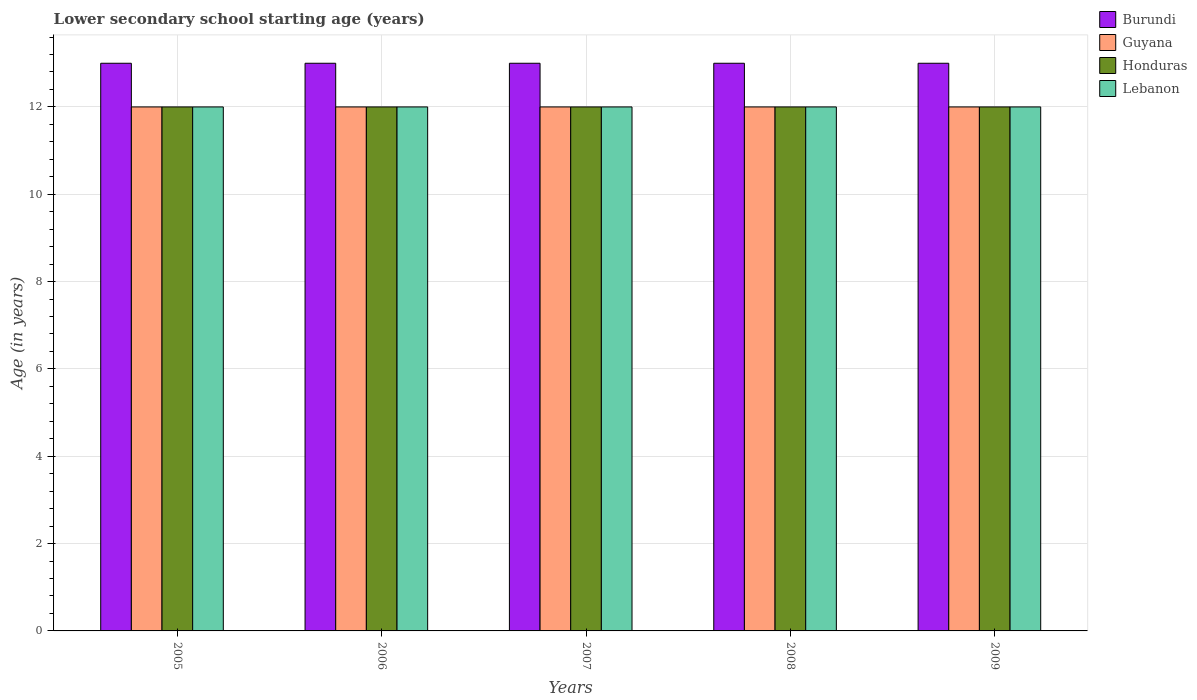Are the number of bars on each tick of the X-axis equal?
Your response must be concise. Yes. How many bars are there on the 1st tick from the left?
Offer a very short reply. 4. In how many cases, is the number of bars for a given year not equal to the number of legend labels?
Provide a succinct answer. 0. What is the lower secondary school starting age of children in Guyana in 2006?
Provide a short and direct response. 12. Across all years, what is the maximum lower secondary school starting age of children in Honduras?
Make the answer very short. 12. Across all years, what is the minimum lower secondary school starting age of children in Honduras?
Offer a very short reply. 12. In which year was the lower secondary school starting age of children in Guyana maximum?
Give a very brief answer. 2005. What is the total lower secondary school starting age of children in Lebanon in the graph?
Your response must be concise. 60. In the year 2005, what is the difference between the lower secondary school starting age of children in Lebanon and lower secondary school starting age of children in Burundi?
Ensure brevity in your answer.  -1. In how many years, is the lower secondary school starting age of children in Burundi greater than 11.6 years?
Give a very brief answer. 5. What is the ratio of the lower secondary school starting age of children in Burundi in 2005 to that in 2007?
Your response must be concise. 1. Is the lower secondary school starting age of children in Honduras in 2006 less than that in 2009?
Provide a succinct answer. No. Is the difference between the lower secondary school starting age of children in Lebanon in 2007 and 2009 greater than the difference between the lower secondary school starting age of children in Burundi in 2007 and 2009?
Offer a very short reply. No. What is the difference between the highest and the second highest lower secondary school starting age of children in Guyana?
Make the answer very short. 0. What is the difference between the highest and the lowest lower secondary school starting age of children in Guyana?
Offer a very short reply. 0. In how many years, is the lower secondary school starting age of children in Guyana greater than the average lower secondary school starting age of children in Guyana taken over all years?
Your answer should be compact. 0. Is the sum of the lower secondary school starting age of children in Burundi in 2008 and 2009 greater than the maximum lower secondary school starting age of children in Honduras across all years?
Give a very brief answer. Yes. What does the 3rd bar from the left in 2006 represents?
Keep it short and to the point. Honduras. What does the 3rd bar from the right in 2009 represents?
Ensure brevity in your answer.  Guyana. Is it the case that in every year, the sum of the lower secondary school starting age of children in Honduras and lower secondary school starting age of children in Guyana is greater than the lower secondary school starting age of children in Burundi?
Your answer should be very brief. Yes. What is the difference between two consecutive major ticks on the Y-axis?
Provide a succinct answer. 2. What is the title of the graph?
Make the answer very short. Lower secondary school starting age (years). Does "Italy" appear as one of the legend labels in the graph?
Your answer should be compact. No. What is the label or title of the X-axis?
Give a very brief answer. Years. What is the label or title of the Y-axis?
Make the answer very short. Age (in years). What is the Age (in years) of Lebanon in 2005?
Offer a terse response. 12. What is the Age (in years) of Guyana in 2006?
Offer a very short reply. 12. What is the Age (in years) in Honduras in 2006?
Keep it short and to the point. 12. What is the Age (in years) of Guyana in 2007?
Provide a succinct answer. 12. What is the Age (in years) in Honduras in 2007?
Offer a very short reply. 12. What is the Age (in years) in Burundi in 2008?
Provide a succinct answer. 13. What is the Age (in years) of Lebanon in 2008?
Your answer should be compact. 12. What is the Age (in years) in Burundi in 2009?
Make the answer very short. 13. What is the Age (in years) of Guyana in 2009?
Your answer should be compact. 12. What is the Age (in years) in Honduras in 2009?
Your response must be concise. 12. Across all years, what is the maximum Age (in years) of Burundi?
Offer a very short reply. 13. Across all years, what is the maximum Age (in years) in Honduras?
Your response must be concise. 12. Across all years, what is the minimum Age (in years) of Honduras?
Ensure brevity in your answer.  12. What is the total Age (in years) of Honduras in the graph?
Offer a very short reply. 60. What is the difference between the Age (in years) of Guyana in 2005 and that in 2006?
Ensure brevity in your answer.  0. What is the difference between the Age (in years) of Guyana in 2005 and that in 2007?
Provide a short and direct response. 0. What is the difference between the Age (in years) of Honduras in 2005 and that in 2007?
Ensure brevity in your answer.  0. What is the difference between the Age (in years) in Lebanon in 2005 and that in 2007?
Your response must be concise. 0. What is the difference between the Age (in years) of Burundi in 2005 and that in 2008?
Offer a terse response. 0. What is the difference between the Age (in years) in Guyana in 2005 and that in 2008?
Make the answer very short. 0. What is the difference between the Age (in years) of Guyana in 2005 and that in 2009?
Your response must be concise. 0. What is the difference between the Age (in years) in Honduras in 2005 and that in 2009?
Your answer should be very brief. 0. What is the difference between the Age (in years) in Lebanon in 2005 and that in 2009?
Give a very brief answer. 0. What is the difference between the Age (in years) of Guyana in 2006 and that in 2007?
Make the answer very short. 0. What is the difference between the Age (in years) in Honduras in 2006 and that in 2007?
Your answer should be very brief. 0. What is the difference between the Age (in years) of Lebanon in 2006 and that in 2007?
Ensure brevity in your answer.  0. What is the difference between the Age (in years) of Guyana in 2006 and that in 2008?
Your answer should be compact. 0. What is the difference between the Age (in years) in Honduras in 2006 and that in 2008?
Your answer should be very brief. 0. What is the difference between the Age (in years) of Lebanon in 2006 and that in 2008?
Keep it short and to the point. 0. What is the difference between the Age (in years) in Burundi in 2006 and that in 2009?
Provide a short and direct response. 0. What is the difference between the Age (in years) in Honduras in 2006 and that in 2009?
Offer a terse response. 0. What is the difference between the Age (in years) in Lebanon in 2006 and that in 2009?
Your answer should be compact. 0. What is the difference between the Age (in years) of Guyana in 2007 and that in 2008?
Your response must be concise. 0. What is the difference between the Age (in years) in Lebanon in 2007 and that in 2009?
Offer a very short reply. 0. What is the difference between the Age (in years) of Burundi in 2008 and that in 2009?
Your response must be concise. 0. What is the difference between the Age (in years) of Burundi in 2005 and the Age (in years) of Guyana in 2006?
Your response must be concise. 1. What is the difference between the Age (in years) in Guyana in 2005 and the Age (in years) in Honduras in 2006?
Your answer should be very brief. 0. What is the difference between the Age (in years) in Guyana in 2005 and the Age (in years) in Lebanon in 2006?
Offer a terse response. 0. What is the difference between the Age (in years) of Honduras in 2005 and the Age (in years) of Lebanon in 2006?
Offer a terse response. 0. What is the difference between the Age (in years) of Guyana in 2005 and the Age (in years) of Honduras in 2007?
Make the answer very short. 0. What is the difference between the Age (in years) of Honduras in 2005 and the Age (in years) of Lebanon in 2007?
Offer a terse response. 0. What is the difference between the Age (in years) of Burundi in 2005 and the Age (in years) of Guyana in 2008?
Offer a terse response. 1. What is the difference between the Age (in years) in Honduras in 2005 and the Age (in years) in Lebanon in 2008?
Make the answer very short. 0. What is the difference between the Age (in years) in Burundi in 2005 and the Age (in years) in Honduras in 2009?
Make the answer very short. 1. What is the difference between the Age (in years) of Guyana in 2005 and the Age (in years) of Honduras in 2009?
Make the answer very short. 0. What is the difference between the Age (in years) in Honduras in 2005 and the Age (in years) in Lebanon in 2009?
Your answer should be very brief. 0. What is the difference between the Age (in years) of Burundi in 2006 and the Age (in years) of Guyana in 2007?
Keep it short and to the point. 1. What is the difference between the Age (in years) in Burundi in 2006 and the Age (in years) in Honduras in 2007?
Ensure brevity in your answer.  1. What is the difference between the Age (in years) of Burundi in 2006 and the Age (in years) of Lebanon in 2007?
Provide a short and direct response. 1. What is the difference between the Age (in years) of Guyana in 2006 and the Age (in years) of Lebanon in 2007?
Provide a short and direct response. 0. What is the difference between the Age (in years) of Burundi in 2006 and the Age (in years) of Lebanon in 2008?
Keep it short and to the point. 1. What is the difference between the Age (in years) in Honduras in 2006 and the Age (in years) in Lebanon in 2008?
Keep it short and to the point. 0. What is the difference between the Age (in years) of Burundi in 2006 and the Age (in years) of Guyana in 2009?
Your response must be concise. 1. What is the difference between the Age (in years) of Burundi in 2006 and the Age (in years) of Honduras in 2009?
Offer a terse response. 1. What is the difference between the Age (in years) in Guyana in 2006 and the Age (in years) in Honduras in 2009?
Give a very brief answer. 0. What is the difference between the Age (in years) of Guyana in 2006 and the Age (in years) of Lebanon in 2009?
Offer a terse response. 0. What is the difference between the Age (in years) of Burundi in 2007 and the Age (in years) of Guyana in 2008?
Offer a very short reply. 1. What is the difference between the Age (in years) in Burundi in 2007 and the Age (in years) in Lebanon in 2008?
Provide a succinct answer. 1. What is the difference between the Age (in years) in Honduras in 2007 and the Age (in years) in Lebanon in 2008?
Your answer should be very brief. 0. What is the difference between the Age (in years) of Burundi in 2007 and the Age (in years) of Guyana in 2009?
Provide a short and direct response. 1. What is the difference between the Age (in years) in Burundi in 2007 and the Age (in years) in Honduras in 2009?
Your answer should be very brief. 1. What is the difference between the Age (in years) in Guyana in 2007 and the Age (in years) in Honduras in 2009?
Give a very brief answer. 0. What is the difference between the Age (in years) of Burundi in 2008 and the Age (in years) of Guyana in 2009?
Offer a very short reply. 1. What is the difference between the Age (in years) of Burundi in 2008 and the Age (in years) of Lebanon in 2009?
Ensure brevity in your answer.  1. What is the difference between the Age (in years) in Guyana in 2008 and the Age (in years) in Honduras in 2009?
Ensure brevity in your answer.  0. What is the difference between the Age (in years) of Guyana in 2008 and the Age (in years) of Lebanon in 2009?
Provide a succinct answer. 0. In the year 2005, what is the difference between the Age (in years) in Burundi and Age (in years) in Guyana?
Give a very brief answer. 1. In the year 2005, what is the difference between the Age (in years) in Burundi and Age (in years) in Honduras?
Keep it short and to the point. 1. In the year 2005, what is the difference between the Age (in years) in Burundi and Age (in years) in Lebanon?
Your answer should be compact. 1. In the year 2005, what is the difference between the Age (in years) in Guyana and Age (in years) in Honduras?
Your answer should be very brief. 0. In the year 2005, what is the difference between the Age (in years) in Guyana and Age (in years) in Lebanon?
Keep it short and to the point. 0. In the year 2005, what is the difference between the Age (in years) in Honduras and Age (in years) in Lebanon?
Give a very brief answer. 0. In the year 2006, what is the difference between the Age (in years) of Burundi and Age (in years) of Guyana?
Make the answer very short. 1. In the year 2006, what is the difference between the Age (in years) in Burundi and Age (in years) in Honduras?
Provide a succinct answer. 1. In the year 2006, what is the difference between the Age (in years) of Burundi and Age (in years) of Lebanon?
Make the answer very short. 1. In the year 2006, what is the difference between the Age (in years) of Guyana and Age (in years) of Honduras?
Give a very brief answer. 0. In the year 2006, what is the difference between the Age (in years) of Honduras and Age (in years) of Lebanon?
Offer a very short reply. 0. In the year 2007, what is the difference between the Age (in years) in Burundi and Age (in years) in Lebanon?
Your answer should be compact. 1. In the year 2007, what is the difference between the Age (in years) in Guyana and Age (in years) in Honduras?
Your answer should be compact. 0. In the year 2007, what is the difference between the Age (in years) of Guyana and Age (in years) of Lebanon?
Make the answer very short. 0. In the year 2007, what is the difference between the Age (in years) of Honduras and Age (in years) of Lebanon?
Provide a succinct answer. 0. In the year 2008, what is the difference between the Age (in years) of Burundi and Age (in years) of Guyana?
Your answer should be very brief. 1. In the year 2008, what is the difference between the Age (in years) in Burundi and Age (in years) in Honduras?
Keep it short and to the point. 1. In the year 2008, what is the difference between the Age (in years) in Burundi and Age (in years) in Lebanon?
Offer a very short reply. 1. In the year 2008, what is the difference between the Age (in years) in Guyana and Age (in years) in Honduras?
Provide a succinct answer. 0. In the year 2008, what is the difference between the Age (in years) of Honduras and Age (in years) of Lebanon?
Your response must be concise. 0. In the year 2009, what is the difference between the Age (in years) in Burundi and Age (in years) in Guyana?
Keep it short and to the point. 1. In the year 2009, what is the difference between the Age (in years) in Guyana and Age (in years) in Lebanon?
Offer a very short reply. 0. In the year 2009, what is the difference between the Age (in years) in Honduras and Age (in years) in Lebanon?
Give a very brief answer. 0. What is the ratio of the Age (in years) of Guyana in 2005 to that in 2006?
Your answer should be very brief. 1. What is the ratio of the Age (in years) of Honduras in 2005 to that in 2006?
Give a very brief answer. 1. What is the ratio of the Age (in years) of Lebanon in 2005 to that in 2006?
Offer a terse response. 1. What is the ratio of the Age (in years) of Guyana in 2005 to that in 2007?
Offer a terse response. 1. What is the ratio of the Age (in years) in Honduras in 2005 to that in 2007?
Offer a very short reply. 1. What is the ratio of the Age (in years) in Lebanon in 2005 to that in 2007?
Ensure brevity in your answer.  1. What is the ratio of the Age (in years) of Guyana in 2005 to that in 2008?
Provide a succinct answer. 1. What is the ratio of the Age (in years) in Guyana in 2005 to that in 2009?
Make the answer very short. 1. What is the ratio of the Age (in years) of Honduras in 2005 to that in 2009?
Offer a terse response. 1. What is the ratio of the Age (in years) in Lebanon in 2005 to that in 2009?
Provide a succinct answer. 1. What is the ratio of the Age (in years) of Guyana in 2006 to that in 2007?
Offer a very short reply. 1. What is the ratio of the Age (in years) of Honduras in 2006 to that in 2007?
Ensure brevity in your answer.  1. What is the ratio of the Age (in years) of Lebanon in 2006 to that in 2007?
Your answer should be very brief. 1. What is the ratio of the Age (in years) of Honduras in 2006 to that in 2008?
Your answer should be very brief. 1. What is the ratio of the Age (in years) in Burundi in 2006 to that in 2009?
Keep it short and to the point. 1. What is the ratio of the Age (in years) of Guyana in 2006 to that in 2009?
Your response must be concise. 1. What is the ratio of the Age (in years) in Honduras in 2006 to that in 2009?
Offer a terse response. 1. What is the ratio of the Age (in years) in Lebanon in 2006 to that in 2009?
Ensure brevity in your answer.  1. What is the ratio of the Age (in years) in Burundi in 2007 to that in 2008?
Make the answer very short. 1. What is the ratio of the Age (in years) of Guyana in 2007 to that in 2008?
Make the answer very short. 1. What is the ratio of the Age (in years) of Burundi in 2007 to that in 2009?
Give a very brief answer. 1. What is the ratio of the Age (in years) in Guyana in 2008 to that in 2009?
Ensure brevity in your answer.  1. What is the ratio of the Age (in years) of Lebanon in 2008 to that in 2009?
Offer a very short reply. 1. What is the difference between the highest and the second highest Age (in years) in Burundi?
Offer a terse response. 0. What is the difference between the highest and the second highest Age (in years) of Honduras?
Your answer should be compact. 0. What is the difference between the highest and the lowest Age (in years) in Guyana?
Provide a short and direct response. 0. What is the difference between the highest and the lowest Age (in years) of Honduras?
Provide a short and direct response. 0. What is the difference between the highest and the lowest Age (in years) of Lebanon?
Give a very brief answer. 0. 